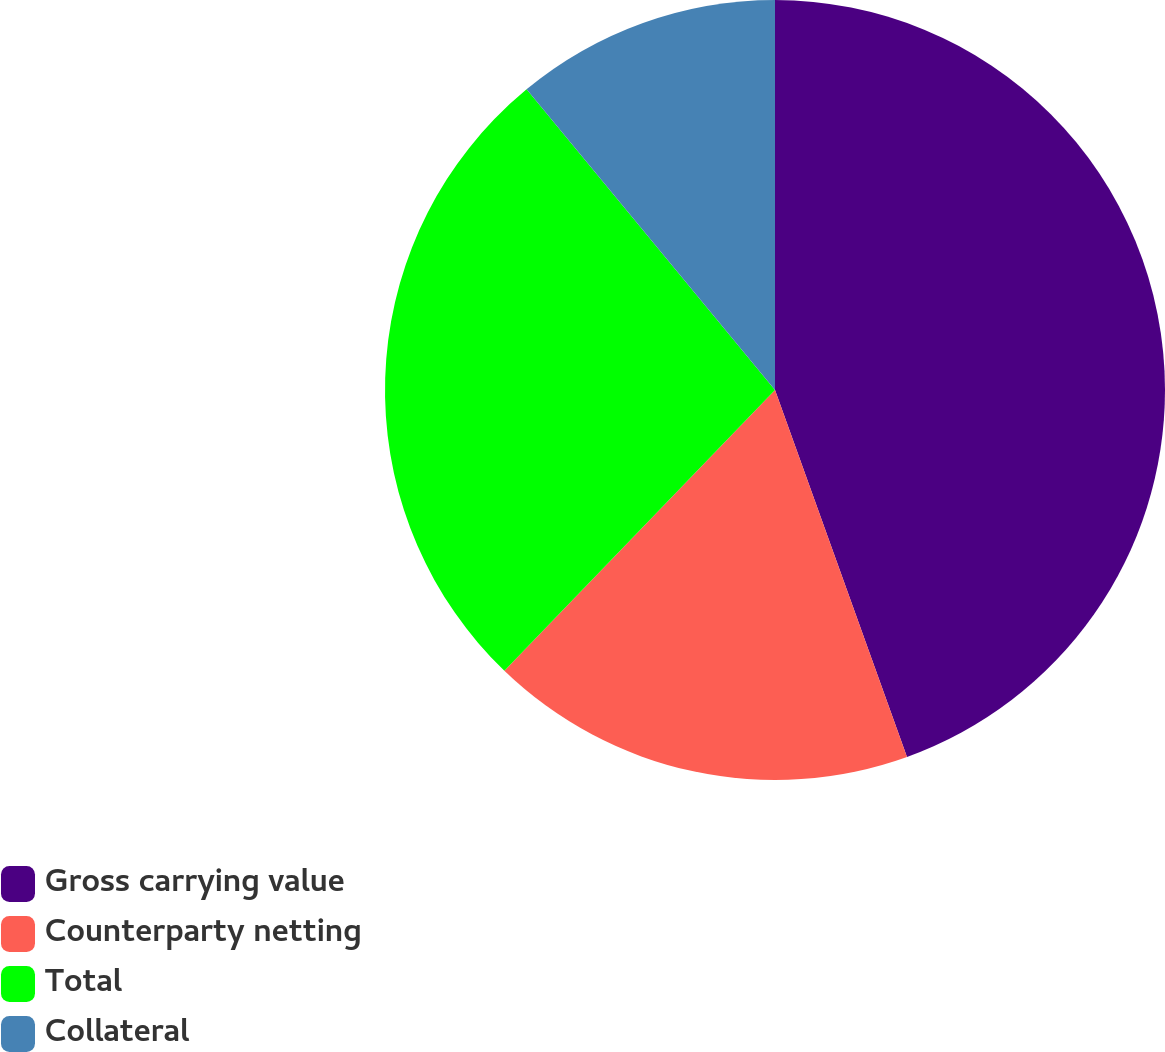<chart> <loc_0><loc_0><loc_500><loc_500><pie_chart><fcel>Gross carrying value<fcel>Counterparty netting<fcel>Total<fcel>Collateral<nl><fcel>44.5%<fcel>17.7%<fcel>26.8%<fcel>10.99%<nl></chart> 